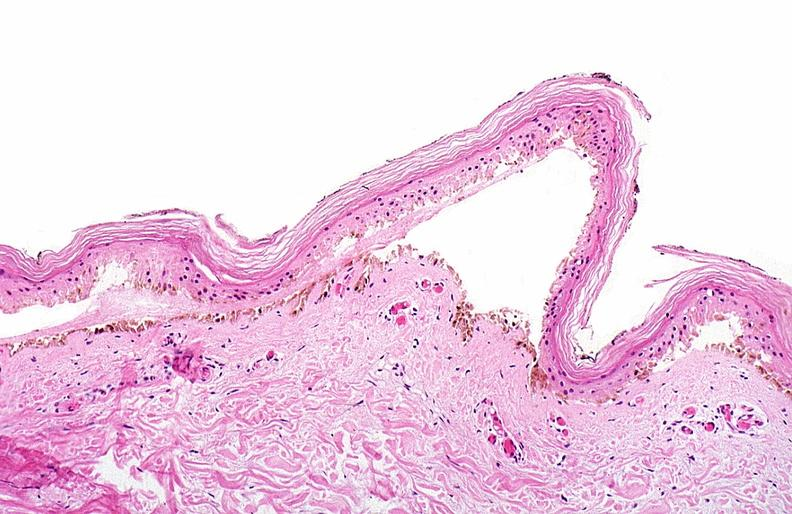what does this image show?
Answer the question using a single word or phrase. Thermal burned skin 